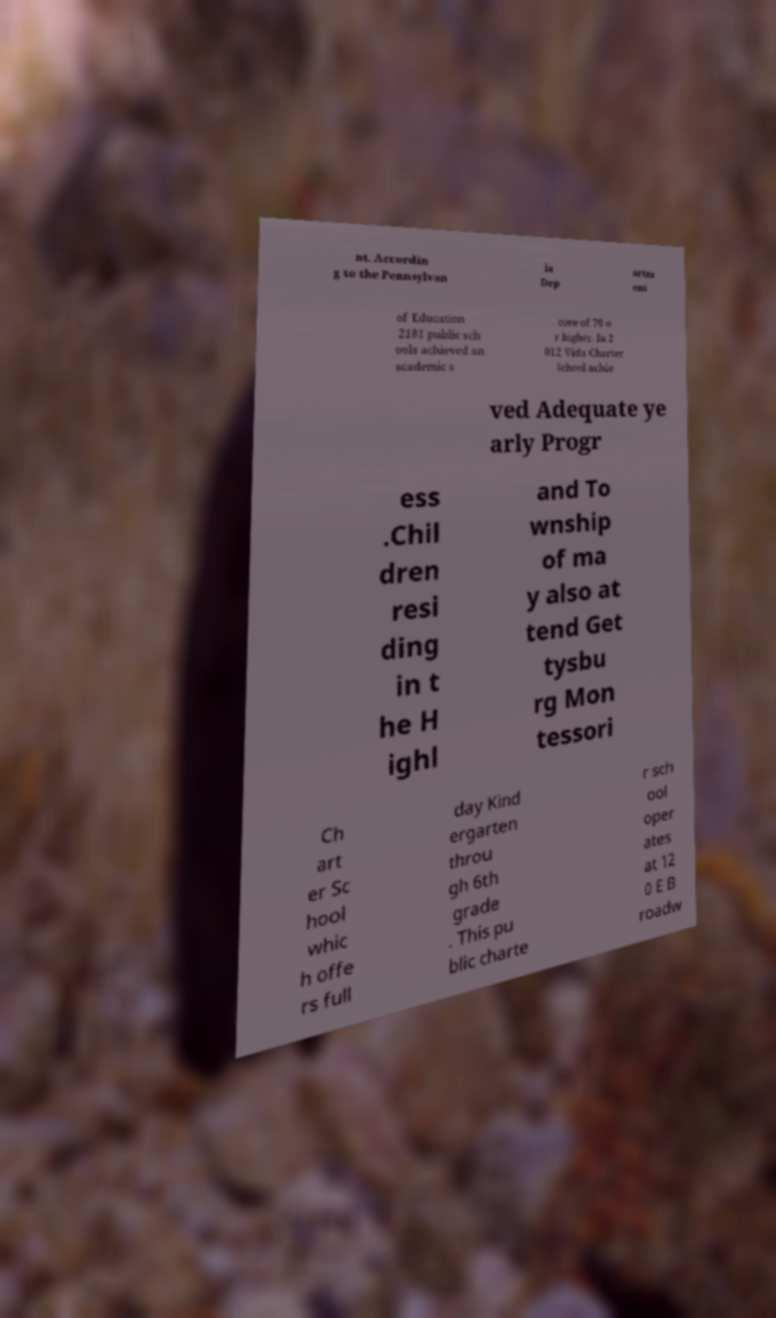I need the written content from this picture converted into text. Can you do that? nt. Accordin g to the Pennsylvan ia Dep artm ent of Education 2181 public sch ools achieved an academic s core of 70 o r higher. In 2 012 Vida Charter School achie ved Adequate ye arly Progr ess .Chil dren resi ding in t he H ighl and To wnship of ma y also at tend Get tysbu rg Mon tessori Ch art er Sc hool whic h offe rs full day Kind ergarten throu gh 6th grade . This pu blic charte r sch ool oper ates at 12 0 E B roadw 